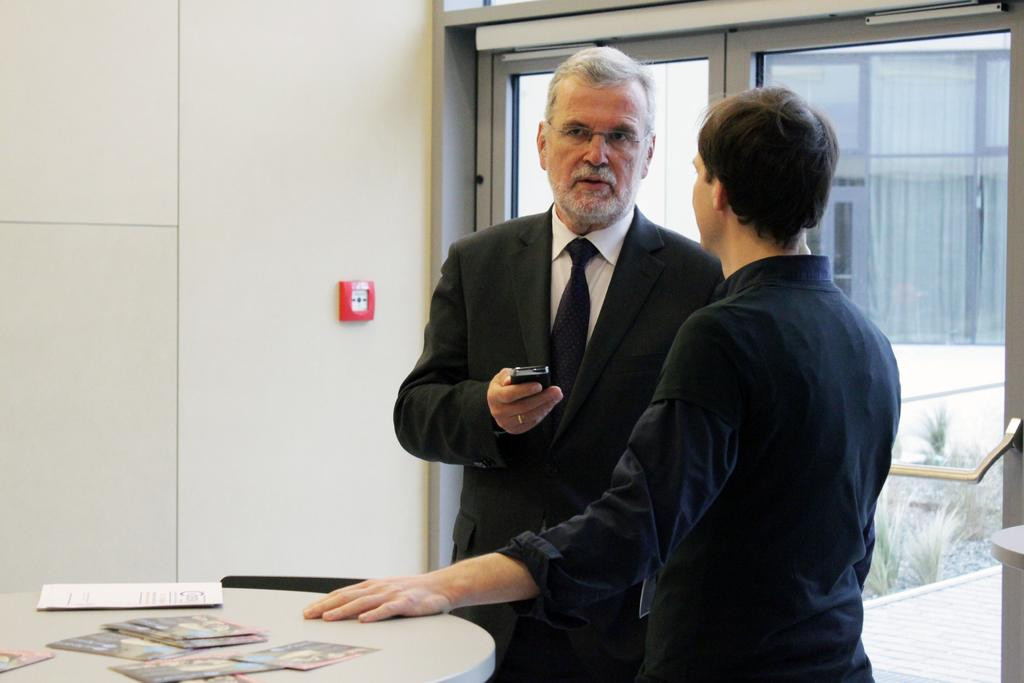How many people are in the image? There are two persons standing in the image. What is the surface they are standing on? The persons are standing on the floor. What other objects can be seen in the image? There is a table in the image. What type of background is visible in the image? There is a wall in the image. Is there any access to the outdoors visible in the image? Yes, there is a glass door in the image. What type of shock can be seen on the person's face in the image? There is no shock visible on the person's face in the image. What type of prison is depicted in the image? There is no prison present in the image. 